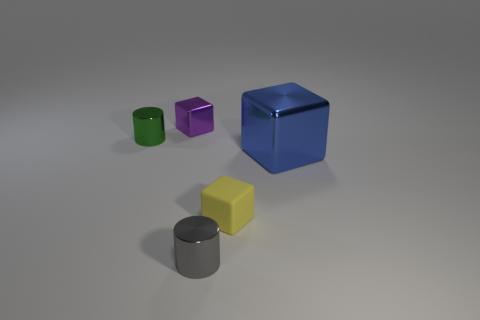The large object that is the same material as the tiny purple object is what shape?
Give a very brief answer. Cube. Do the blue thing and the green metallic thing have the same size?
Your answer should be very brief. No. What is the size of the metal object that is on the right side of the metal cylinder in front of the small yellow block?
Your answer should be very brief. Large. How many blocks are either large objects or yellow matte things?
Give a very brief answer. 2. Do the gray metal cylinder and the shiny block in front of the green metallic cylinder have the same size?
Your answer should be very brief. No. Are there more shiny things that are behind the small green cylinder than small gray balls?
Your response must be concise. Yes. What is the size of the blue object that is the same material as the tiny gray thing?
Ensure brevity in your answer.  Large. What number of objects are either big gray metallic blocks or gray shiny cylinders that are right of the purple metallic cube?
Provide a short and direct response. 1. Are there more tiny cyan shiny cylinders than big shiny blocks?
Offer a very short reply. No. Are there any blue things that have the same material as the green object?
Offer a very short reply. Yes. 